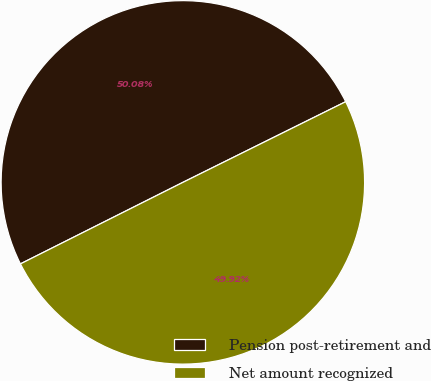Convert chart to OTSL. <chart><loc_0><loc_0><loc_500><loc_500><pie_chart><fcel>Pension post-retirement and<fcel>Net amount recognized<nl><fcel>50.08%<fcel>49.92%<nl></chart> 